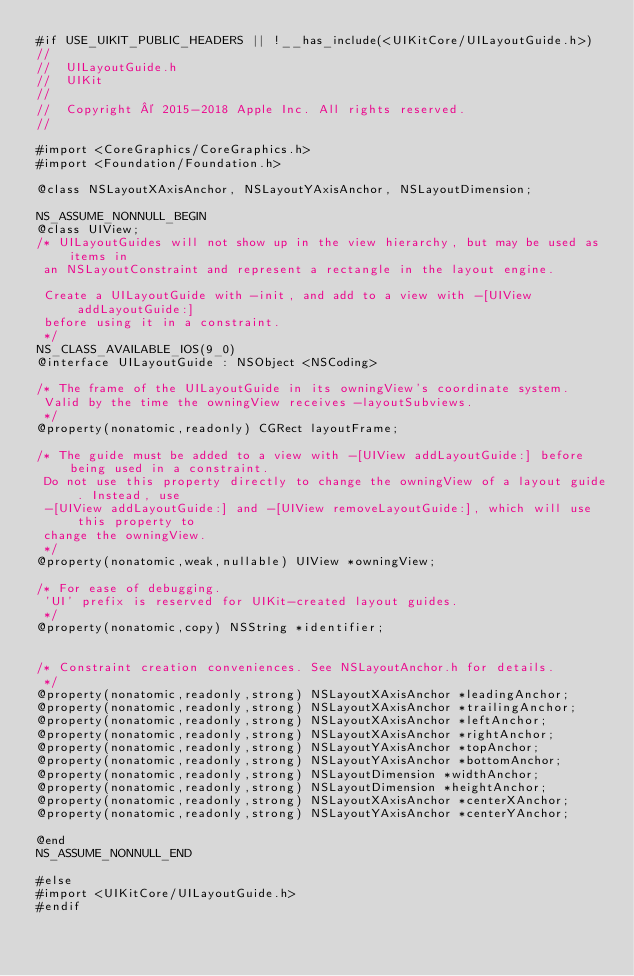<code> <loc_0><loc_0><loc_500><loc_500><_C_>#if USE_UIKIT_PUBLIC_HEADERS || !__has_include(<UIKitCore/UILayoutGuide.h>)
//
//  UILayoutGuide.h
//  UIKit
//
//  Copyright © 2015-2018 Apple Inc. All rights reserved.
//

#import <CoreGraphics/CoreGraphics.h>
#import <Foundation/Foundation.h>

@class NSLayoutXAxisAnchor, NSLayoutYAxisAnchor, NSLayoutDimension;

NS_ASSUME_NONNULL_BEGIN
@class UIView;
/* UILayoutGuides will not show up in the view hierarchy, but may be used as items in
 an NSLayoutConstraint and represent a rectangle in the layout engine.
 
 Create a UILayoutGuide with -init, and add to a view with -[UIView addLayoutGuide:]
 before using it in a constraint.
 */
NS_CLASS_AVAILABLE_IOS(9_0)
@interface UILayoutGuide : NSObject <NSCoding>

/* The frame of the UILayoutGuide in its owningView's coordinate system.
 Valid by the time the owningView receives -layoutSubviews.
 */
@property(nonatomic,readonly) CGRect layoutFrame;

/* The guide must be added to a view with -[UIView addLayoutGuide:] before being used in a constraint.
 Do not use this property directly to change the owningView of a layout guide. Instead, use 
 -[UIView addLayoutGuide:] and -[UIView removeLayoutGuide:], which will use this property to 
 change the owningView.
 */
@property(nonatomic,weak,nullable) UIView *owningView;

/* For ease of debugging.
 'UI' prefix is reserved for UIKit-created layout guides.
 */
@property(nonatomic,copy) NSString *identifier;


/* Constraint creation conveniences. See NSLayoutAnchor.h for details.
 */
@property(nonatomic,readonly,strong) NSLayoutXAxisAnchor *leadingAnchor;
@property(nonatomic,readonly,strong) NSLayoutXAxisAnchor *trailingAnchor;
@property(nonatomic,readonly,strong) NSLayoutXAxisAnchor *leftAnchor;
@property(nonatomic,readonly,strong) NSLayoutXAxisAnchor *rightAnchor;
@property(nonatomic,readonly,strong) NSLayoutYAxisAnchor *topAnchor;
@property(nonatomic,readonly,strong) NSLayoutYAxisAnchor *bottomAnchor;
@property(nonatomic,readonly,strong) NSLayoutDimension *widthAnchor;
@property(nonatomic,readonly,strong) NSLayoutDimension *heightAnchor;
@property(nonatomic,readonly,strong) NSLayoutXAxisAnchor *centerXAnchor;
@property(nonatomic,readonly,strong) NSLayoutYAxisAnchor *centerYAnchor;

@end
NS_ASSUME_NONNULL_END

#else
#import <UIKitCore/UILayoutGuide.h>
#endif
</code> 